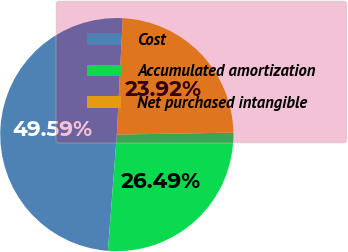<chart> <loc_0><loc_0><loc_500><loc_500><pie_chart><fcel>Cost<fcel>Accumulated amortization<fcel>Net purchased intangible<nl><fcel>49.59%<fcel>26.49%<fcel>23.92%<nl></chart> 